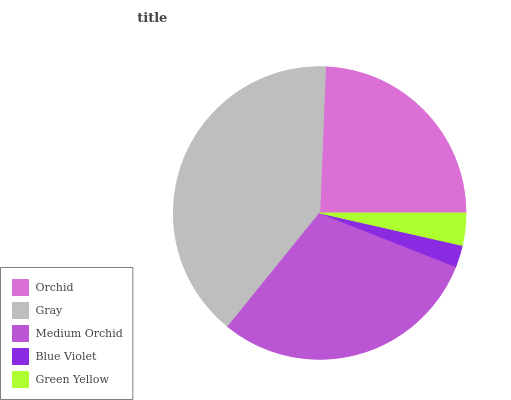Is Blue Violet the minimum?
Answer yes or no. Yes. Is Gray the maximum?
Answer yes or no. Yes. Is Medium Orchid the minimum?
Answer yes or no. No. Is Medium Orchid the maximum?
Answer yes or no. No. Is Gray greater than Medium Orchid?
Answer yes or no. Yes. Is Medium Orchid less than Gray?
Answer yes or no. Yes. Is Medium Orchid greater than Gray?
Answer yes or no. No. Is Gray less than Medium Orchid?
Answer yes or no. No. Is Orchid the high median?
Answer yes or no. Yes. Is Orchid the low median?
Answer yes or no. Yes. Is Blue Violet the high median?
Answer yes or no. No. Is Gray the low median?
Answer yes or no. No. 